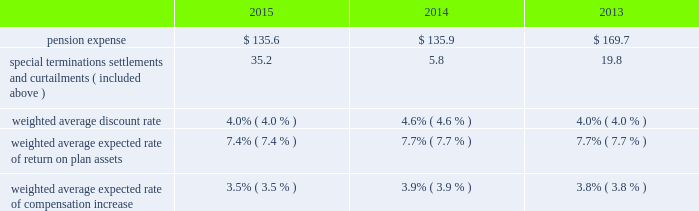Unconditional purchase obligations approximately $ 390 of our long-term unconditional purchase obligations relate to feedstock supply for numerous hyco ( hydrogen , carbon monoxide , and syngas ) facilities .
The price of feedstock supply is principally related to the price of natural gas .
However , long-term take-or-pay sales contracts to hyco customers are generally matched to the term of the feedstock supply obligations and provide recovery of price increases in the feedstock supply .
Due to the matching of most long-term feedstock supply obligations to customer sales contracts , we do not believe these purchase obligations would have a material effect on our financial condition or results of operations .
Refer to note 17 , commitments and contingencies , to the consolidated financial statements for additional information on our unconditional purchase obligations .
The unconditional purchase obligations also include other product supply and purchase commitments and electric power and natural gas supply purchase obligations , which are primarily pass-through contracts with our customers .
In addition , purchase commitments to spend approximately $ 540 for additional plant and equipment are included in the unconditional purchase obligations in 2016 .
We also purchase materials , energy , capital equipment , supplies , and services as part of the ordinary course of business under arrangements that are not unconditional purchase obligations .
The majority of such purchases are for raw materials and energy , which are obtained under requirements-type contracts at market prices .
Obligation for future contribution to an equity affiliate on 19 april 2015 , a joint venture between air products and acwa holding entered into a 20-year oxygen and nitrogen supply agreement to supply saudi aramco 2019s oil refinery and power plant being built in jazan , saudi arabia .
Air products owns 25% ( 25 % ) of the joint venture and guarantees the repayment of its share of an equity bridge loan .
In total , we expect to invest approximately $ 100 in this joint venture .
As of 30 september 2015 , we recorded a noncurrent liability of $ 67.5 for our obligation to make future equity contributions based on advances received by the joint venture under the loan .
Income tax liabilities noncurrent deferred income tax liabilities as of 30 september 2015 were $ 903.3 .
Tax liabilities related to unrecognized tax benefits as of 30 september 2015 were $ 97.5 .
These tax liabilities were excluded from the contractual obligations table , as it is impractical to determine a cash impact by year given that payments will vary according to changes in tax laws , tax rates , and our operating results .
In addition , there are uncertainties in timing of the effective settlement of our uncertain tax positions with respective taxing authorities .
Refer to note 23 , income taxes , to the consolidated financial statements for additional information .
Pension benefits the company sponsors defined benefit pension plans and defined contribution plans that cover a substantial portion of its worldwide employees .
The principal defined benefit pension plans 2014the u.s .
Salaried pension plan and the u.k .
Pension plan 2014were closed to new participants in 2005 and were replaced with defined contribution plans .
Over the long run , the shift to defined contribution plans is expected to reduce volatility of both plan expense and contributions .
The fair market value of plan assets for our defined benefit pension plans as of the 30 september 2015 measurement date decreased to $ 3916.4 from $ 4114.6 at the end of fiscal year 2014 .
The projected benefit obligation for these plans was $ 4787.8 and $ 4738.6 at the end of the fiscal years 2015 and 2014 , respectively .
Refer to note 16 , retirement benefits , to the consolidated financial statements for comprehensive and detailed disclosures on our postretirement benefits .
Pension expense .

What was the decrease observed in the fair market value of plan assets of the benefit pension plans during 2014 and 2015? 
Rationale: it is the final 2015 value subtracted by the initial 2014 value then divided by the initial value and turned into a percentage.\\n
Computations: ((3916.4 - 4114.6) / 4114.6)
Answer: -0.04817. 